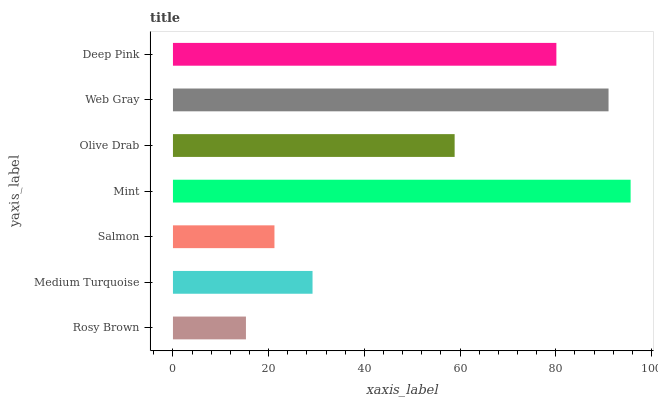Is Rosy Brown the minimum?
Answer yes or no. Yes. Is Mint the maximum?
Answer yes or no. Yes. Is Medium Turquoise the minimum?
Answer yes or no. No. Is Medium Turquoise the maximum?
Answer yes or no. No. Is Medium Turquoise greater than Rosy Brown?
Answer yes or no. Yes. Is Rosy Brown less than Medium Turquoise?
Answer yes or no. Yes. Is Rosy Brown greater than Medium Turquoise?
Answer yes or no. No. Is Medium Turquoise less than Rosy Brown?
Answer yes or no. No. Is Olive Drab the high median?
Answer yes or no. Yes. Is Olive Drab the low median?
Answer yes or no. Yes. Is Mint the high median?
Answer yes or no. No. Is Mint the low median?
Answer yes or no. No. 